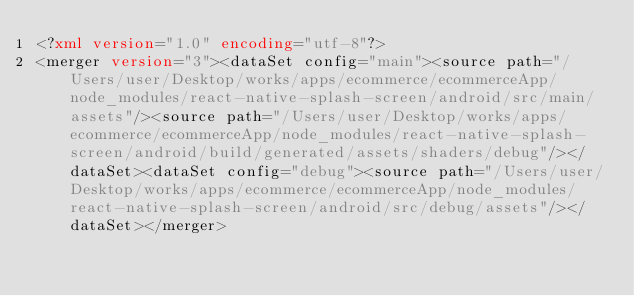Convert code to text. <code><loc_0><loc_0><loc_500><loc_500><_XML_><?xml version="1.0" encoding="utf-8"?>
<merger version="3"><dataSet config="main"><source path="/Users/user/Desktop/works/apps/ecommerce/ecommerceApp/node_modules/react-native-splash-screen/android/src/main/assets"/><source path="/Users/user/Desktop/works/apps/ecommerce/ecommerceApp/node_modules/react-native-splash-screen/android/build/generated/assets/shaders/debug"/></dataSet><dataSet config="debug"><source path="/Users/user/Desktop/works/apps/ecommerce/ecommerceApp/node_modules/react-native-splash-screen/android/src/debug/assets"/></dataSet></merger></code> 